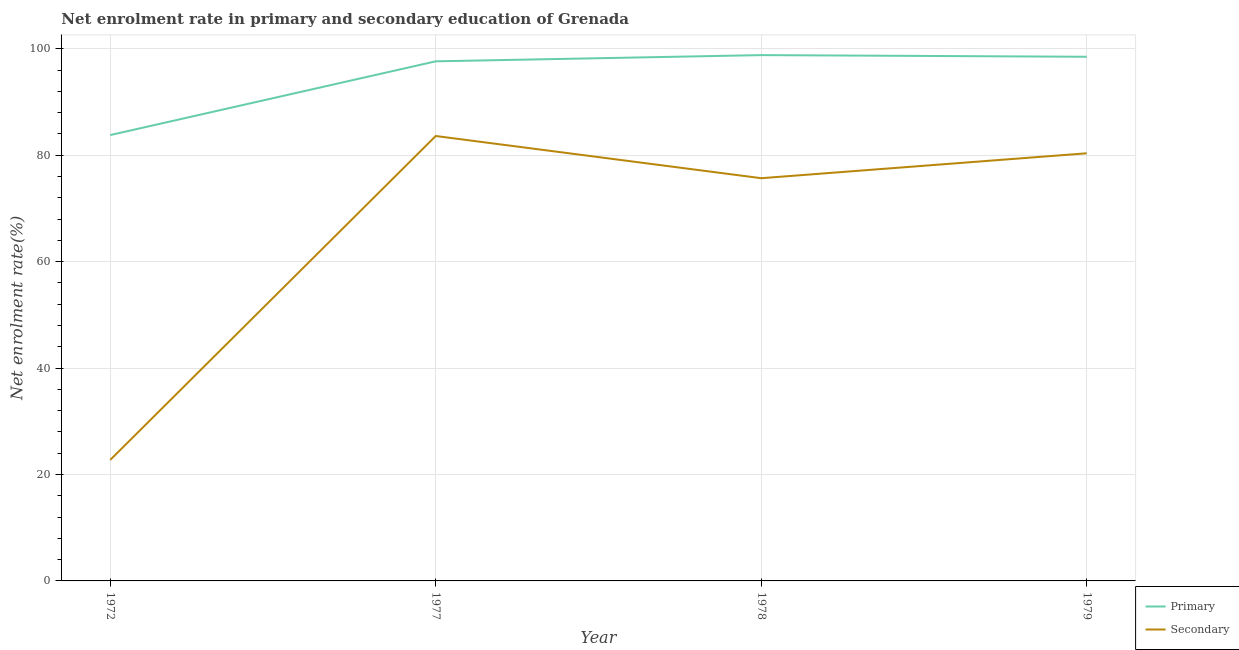Is the number of lines equal to the number of legend labels?
Provide a succinct answer. Yes. What is the enrollment rate in secondary education in 1978?
Your answer should be compact. 75.67. Across all years, what is the maximum enrollment rate in secondary education?
Provide a short and direct response. 83.6. Across all years, what is the minimum enrollment rate in primary education?
Give a very brief answer. 83.77. In which year was the enrollment rate in primary education maximum?
Ensure brevity in your answer.  1978. What is the total enrollment rate in secondary education in the graph?
Provide a short and direct response. 262.36. What is the difference between the enrollment rate in secondary education in 1977 and that in 1979?
Your answer should be very brief. 3.25. What is the difference between the enrollment rate in primary education in 1978 and the enrollment rate in secondary education in 1977?
Ensure brevity in your answer.  15.2. What is the average enrollment rate in primary education per year?
Your answer should be compact. 94.67. In the year 1979, what is the difference between the enrollment rate in secondary education and enrollment rate in primary education?
Give a very brief answer. -18.13. What is the ratio of the enrollment rate in secondary education in 1972 to that in 1977?
Give a very brief answer. 0.27. What is the difference between the highest and the second highest enrollment rate in secondary education?
Your answer should be compact. 3.25. What is the difference between the highest and the lowest enrollment rate in primary education?
Your response must be concise. 15.02. Is the sum of the enrollment rate in secondary education in 1972 and 1978 greater than the maximum enrollment rate in primary education across all years?
Ensure brevity in your answer.  No. Does the enrollment rate in primary education monotonically increase over the years?
Ensure brevity in your answer.  No. Is the enrollment rate in secondary education strictly less than the enrollment rate in primary education over the years?
Provide a short and direct response. Yes. How many lines are there?
Provide a succinct answer. 2. How many years are there in the graph?
Your answer should be very brief. 4. What is the difference between two consecutive major ticks on the Y-axis?
Your response must be concise. 20. Are the values on the major ticks of Y-axis written in scientific E-notation?
Offer a very short reply. No. How many legend labels are there?
Your answer should be compact. 2. What is the title of the graph?
Offer a very short reply. Net enrolment rate in primary and secondary education of Grenada. What is the label or title of the Y-axis?
Your answer should be compact. Net enrolment rate(%). What is the Net enrolment rate(%) of Primary in 1972?
Offer a terse response. 83.77. What is the Net enrolment rate(%) of Secondary in 1972?
Your answer should be compact. 22.74. What is the Net enrolment rate(%) in Primary in 1977?
Ensure brevity in your answer.  97.63. What is the Net enrolment rate(%) in Secondary in 1977?
Give a very brief answer. 83.6. What is the Net enrolment rate(%) of Primary in 1978?
Ensure brevity in your answer.  98.8. What is the Net enrolment rate(%) in Secondary in 1978?
Your answer should be compact. 75.67. What is the Net enrolment rate(%) in Primary in 1979?
Your response must be concise. 98.49. What is the Net enrolment rate(%) in Secondary in 1979?
Provide a short and direct response. 80.35. Across all years, what is the maximum Net enrolment rate(%) in Primary?
Provide a short and direct response. 98.8. Across all years, what is the maximum Net enrolment rate(%) in Secondary?
Give a very brief answer. 83.6. Across all years, what is the minimum Net enrolment rate(%) in Primary?
Provide a succinct answer. 83.77. Across all years, what is the minimum Net enrolment rate(%) of Secondary?
Offer a terse response. 22.74. What is the total Net enrolment rate(%) of Primary in the graph?
Offer a very short reply. 378.69. What is the total Net enrolment rate(%) in Secondary in the graph?
Your answer should be compact. 262.36. What is the difference between the Net enrolment rate(%) of Primary in 1972 and that in 1977?
Your answer should be compact. -13.86. What is the difference between the Net enrolment rate(%) of Secondary in 1972 and that in 1977?
Give a very brief answer. -60.86. What is the difference between the Net enrolment rate(%) of Primary in 1972 and that in 1978?
Offer a very short reply. -15.02. What is the difference between the Net enrolment rate(%) in Secondary in 1972 and that in 1978?
Your response must be concise. -52.93. What is the difference between the Net enrolment rate(%) of Primary in 1972 and that in 1979?
Provide a succinct answer. -14.71. What is the difference between the Net enrolment rate(%) of Secondary in 1972 and that in 1979?
Offer a terse response. -57.62. What is the difference between the Net enrolment rate(%) in Primary in 1977 and that in 1978?
Ensure brevity in your answer.  -1.17. What is the difference between the Net enrolment rate(%) of Secondary in 1977 and that in 1978?
Offer a very short reply. 7.93. What is the difference between the Net enrolment rate(%) in Primary in 1977 and that in 1979?
Offer a terse response. -0.86. What is the difference between the Net enrolment rate(%) in Secondary in 1977 and that in 1979?
Give a very brief answer. 3.25. What is the difference between the Net enrolment rate(%) in Primary in 1978 and that in 1979?
Your answer should be very brief. 0.31. What is the difference between the Net enrolment rate(%) of Secondary in 1978 and that in 1979?
Give a very brief answer. -4.68. What is the difference between the Net enrolment rate(%) in Primary in 1972 and the Net enrolment rate(%) in Secondary in 1977?
Offer a very short reply. 0.18. What is the difference between the Net enrolment rate(%) in Primary in 1972 and the Net enrolment rate(%) in Secondary in 1978?
Offer a terse response. 8.1. What is the difference between the Net enrolment rate(%) in Primary in 1972 and the Net enrolment rate(%) in Secondary in 1979?
Keep it short and to the point. 3.42. What is the difference between the Net enrolment rate(%) of Primary in 1977 and the Net enrolment rate(%) of Secondary in 1978?
Keep it short and to the point. 21.96. What is the difference between the Net enrolment rate(%) of Primary in 1977 and the Net enrolment rate(%) of Secondary in 1979?
Give a very brief answer. 17.28. What is the difference between the Net enrolment rate(%) of Primary in 1978 and the Net enrolment rate(%) of Secondary in 1979?
Your answer should be very brief. 18.45. What is the average Net enrolment rate(%) in Primary per year?
Your response must be concise. 94.67. What is the average Net enrolment rate(%) of Secondary per year?
Your response must be concise. 65.59. In the year 1972, what is the difference between the Net enrolment rate(%) of Primary and Net enrolment rate(%) of Secondary?
Keep it short and to the point. 61.04. In the year 1977, what is the difference between the Net enrolment rate(%) of Primary and Net enrolment rate(%) of Secondary?
Make the answer very short. 14.03. In the year 1978, what is the difference between the Net enrolment rate(%) of Primary and Net enrolment rate(%) of Secondary?
Your response must be concise. 23.13. In the year 1979, what is the difference between the Net enrolment rate(%) in Primary and Net enrolment rate(%) in Secondary?
Your response must be concise. 18.13. What is the ratio of the Net enrolment rate(%) in Primary in 1972 to that in 1977?
Keep it short and to the point. 0.86. What is the ratio of the Net enrolment rate(%) of Secondary in 1972 to that in 1977?
Give a very brief answer. 0.27. What is the ratio of the Net enrolment rate(%) of Primary in 1972 to that in 1978?
Your response must be concise. 0.85. What is the ratio of the Net enrolment rate(%) of Secondary in 1972 to that in 1978?
Make the answer very short. 0.3. What is the ratio of the Net enrolment rate(%) in Primary in 1972 to that in 1979?
Ensure brevity in your answer.  0.85. What is the ratio of the Net enrolment rate(%) in Secondary in 1972 to that in 1979?
Ensure brevity in your answer.  0.28. What is the ratio of the Net enrolment rate(%) of Secondary in 1977 to that in 1978?
Provide a succinct answer. 1.1. What is the ratio of the Net enrolment rate(%) of Primary in 1977 to that in 1979?
Your answer should be compact. 0.99. What is the ratio of the Net enrolment rate(%) of Secondary in 1977 to that in 1979?
Provide a succinct answer. 1.04. What is the ratio of the Net enrolment rate(%) of Secondary in 1978 to that in 1979?
Ensure brevity in your answer.  0.94. What is the difference between the highest and the second highest Net enrolment rate(%) in Primary?
Ensure brevity in your answer.  0.31. What is the difference between the highest and the second highest Net enrolment rate(%) in Secondary?
Make the answer very short. 3.25. What is the difference between the highest and the lowest Net enrolment rate(%) in Primary?
Make the answer very short. 15.02. What is the difference between the highest and the lowest Net enrolment rate(%) in Secondary?
Offer a very short reply. 60.86. 